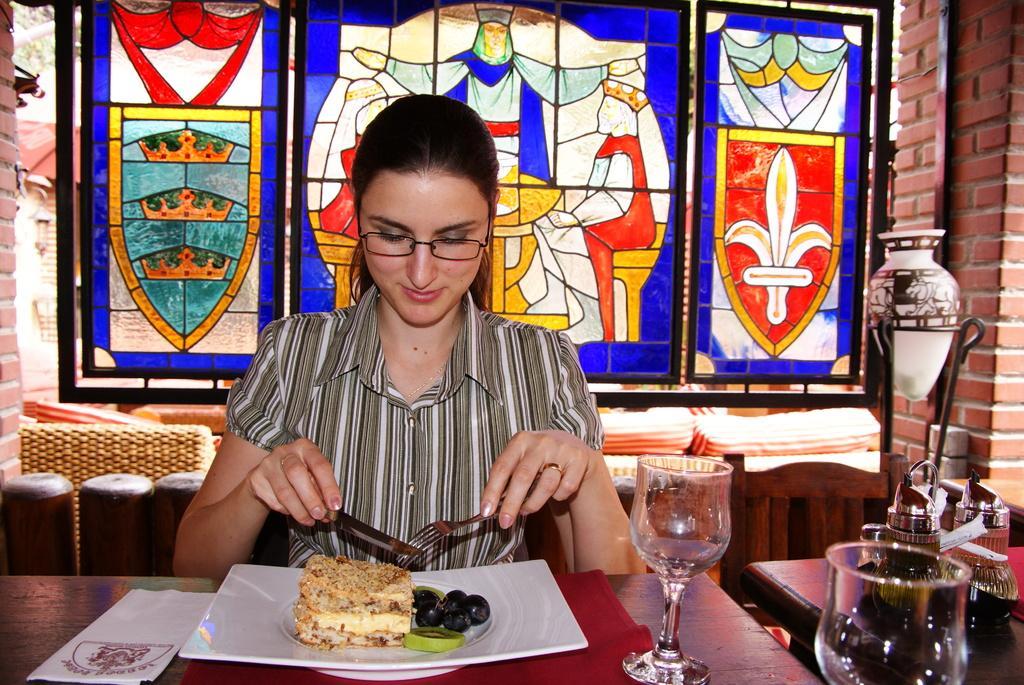In one or two sentences, can you explain what this image depicts? In this image there is a lady sitting around the table and holding a knife and a fork, on the table there are some food items on the plate, a paper and glasses, beside the lady there are few objects on another table, a pot to the stand, windows and the wall. 